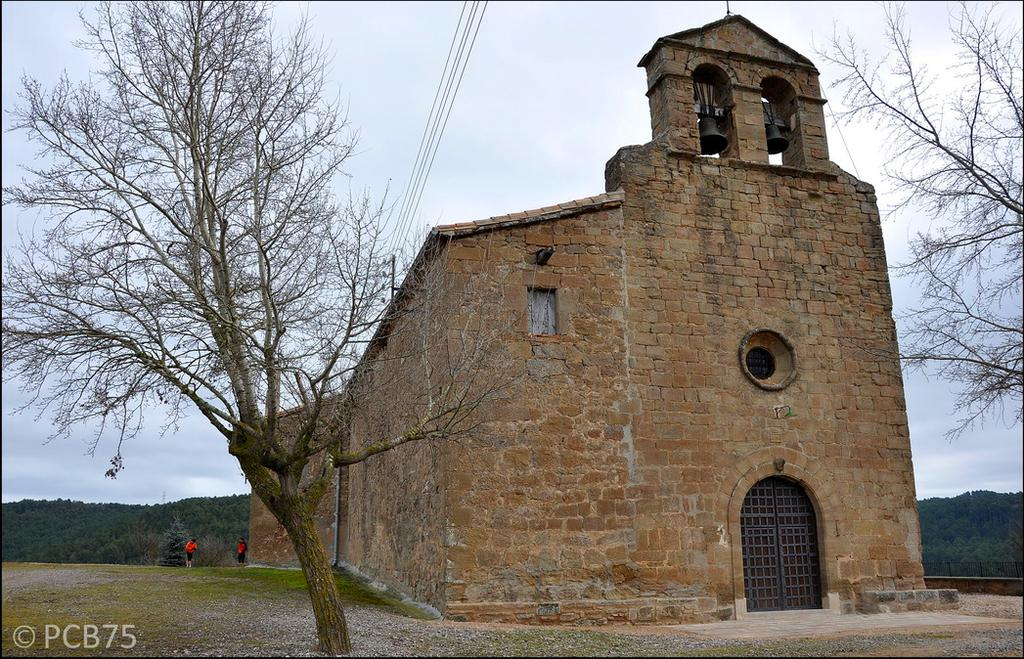What type of structure is present in the image? There is a building in the image. What features can be observed on the building? The building has two beers, a window, and an entrance door. What can be seen in the background of the image? There are many trees in the image. How many people are in the image? There are two persons in the image. What type of furniture can be seen in the image? There is no furniture present in the image. Can you tell me how the cow is interacting with the building in the image? There is no cow present in the image. 